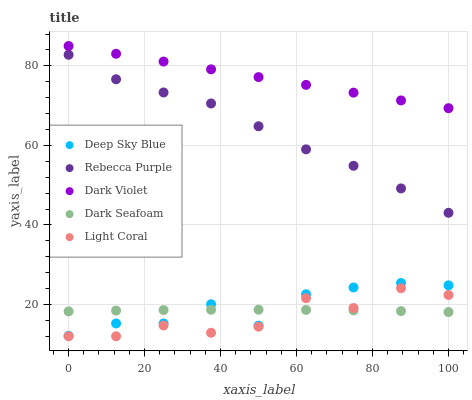Does Light Coral have the minimum area under the curve?
Answer yes or no. Yes. Does Dark Violet have the maximum area under the curve?
Answer yes or no. Yes. Does Dark Violet have the minimum area under the curve?
Answer yes or no. No. Does Light Coral have the maximum area under the curve?
Answer yes or no. No. Is Dark Violet the smoothest?
Answer yes or no. Yes. Is Light Coral the roughest?
Answer yes or no. Yes. Is Light Coral the smoothest?
Answer yes or no. No. Is Dark Violet the roughest?
Answer yes or no. No. Does Light Coral have the lowest value?
Answer yes or no. Yes. Does Dark Violet have the lowest value?
Answer yes or no. No. Does Dark Violet have the highest value?
Answer yes or no. Yes. Does Light Coral have the highest value?
Answer yes or no. No. Is Light Coral less than Deep Sky Blue?
Answer yes or no. Yes. Is Dark Violet greater than Light Coral?
Answer yes or no. Yes. Does Dark Seafoam intersect Deep Sky Blue?
Answer yes or no. Yes. Is Dark Seafoam less than Deep Sky Blue?
Answer yes or no. No. Is Dark Seafoam greater than Deep Sky Blue?
Answer yes or no. No. Does Light Coral intersect Deep Sky Blue?
Answer yes or no. No. 